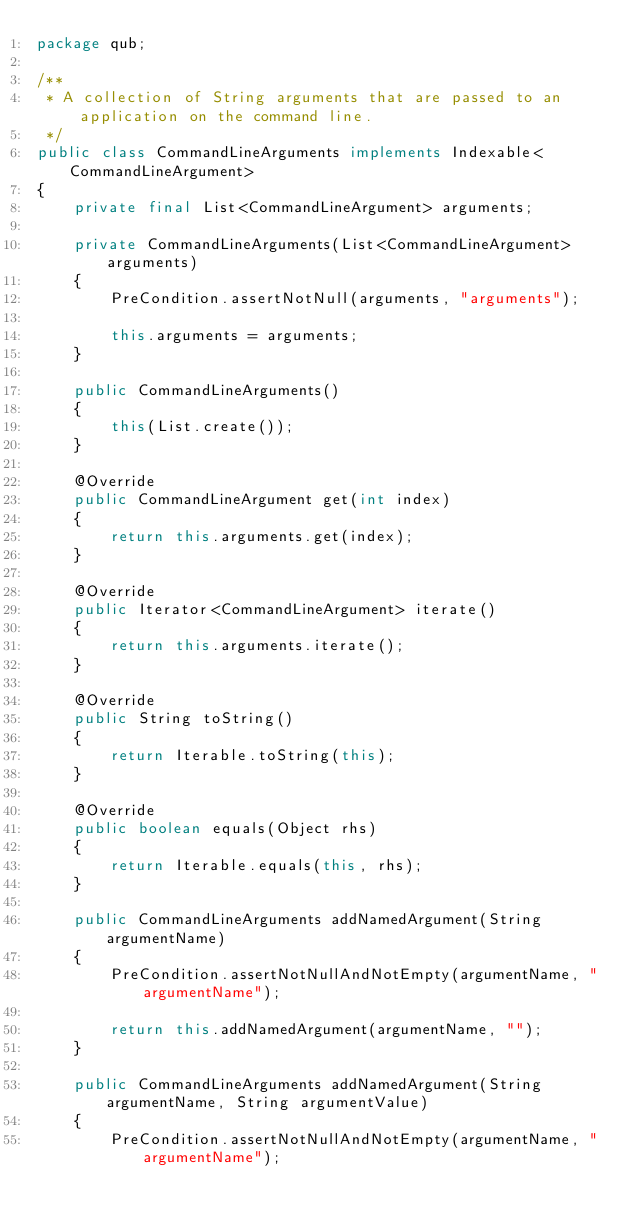<code> <loc_0><loc_0><loc_500><loc_500><_Java_>package qub;

/**
 * A collection of String arguments that are passed to an application on the command line.
 */
public class CommandLineArguments implements Indexable<CommandLineArgument>
{
    private final List<CommandLineArgument> arguments;

    private CommandLineArguments(List<CommandLineArgument> arguments)
    {
        PreCondition.assertNotNull(arguments, "arguments");

        this.arguments = arguments;
    }

    public CommandLineArguments()
    {
        this(List.create());
    }

    @Override
    public CommandLineArgument get(int index)
    {
        return this.arguments.get(index);
    }

    @Override
    public Iterator<CommandLineArgument> iterate()
    {
        return this.arguments.iterate();
    }

    @Override
    public String toString()
    {
        return Iterable.toString(this);
    }

    @Override
    public boolean equals(Object rhs)
    {
        return Iterable.equals(this, rhs);
    }

    public CommandLineArguments addNamedArgument(String argumentName)
    {
        PreCondition.assertNotNullAndNotEmpty(argumentName, "argumentName");

        return this.addNamedArgument(argumentName, "");
    }

    public CommandLineArguments addNamedArgument(String argumentName, String argumentValue)
    {
        PreCondition.assertNotNullAndNotEmpty(argumentName, "argumentName");</code> 